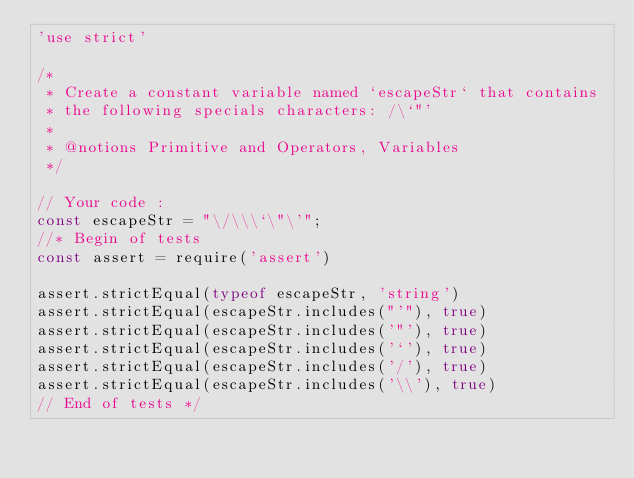<code> <loc_0><loc_0><loc_500><loc_500><_JavaScript_>'use strict'

/*
 * Create a constant variable named `escapeStr` that contains
 * the following specials characters: /\`"'
 *
 * @notions Primitive and Operators, Variables
 */

// Your code :
const escapeStr = "\/\\\`\"\'";
//* Begin of tests
const assert = require('assert')

assert.strictEqual(typeof escapeStr, 'string')
assert.strictEqual(escapeStr.includes("'"), true)
assert.strictEqual(escapeStr.includes('"'), true)
assert.strictEqual(escapeStr.includes('`'), true)
assert.strictEqual(escapeStr.includes('/'), true)
assert.strictEqual(escapeStr.includes('\\'), true)
// End of tests */
</code> 